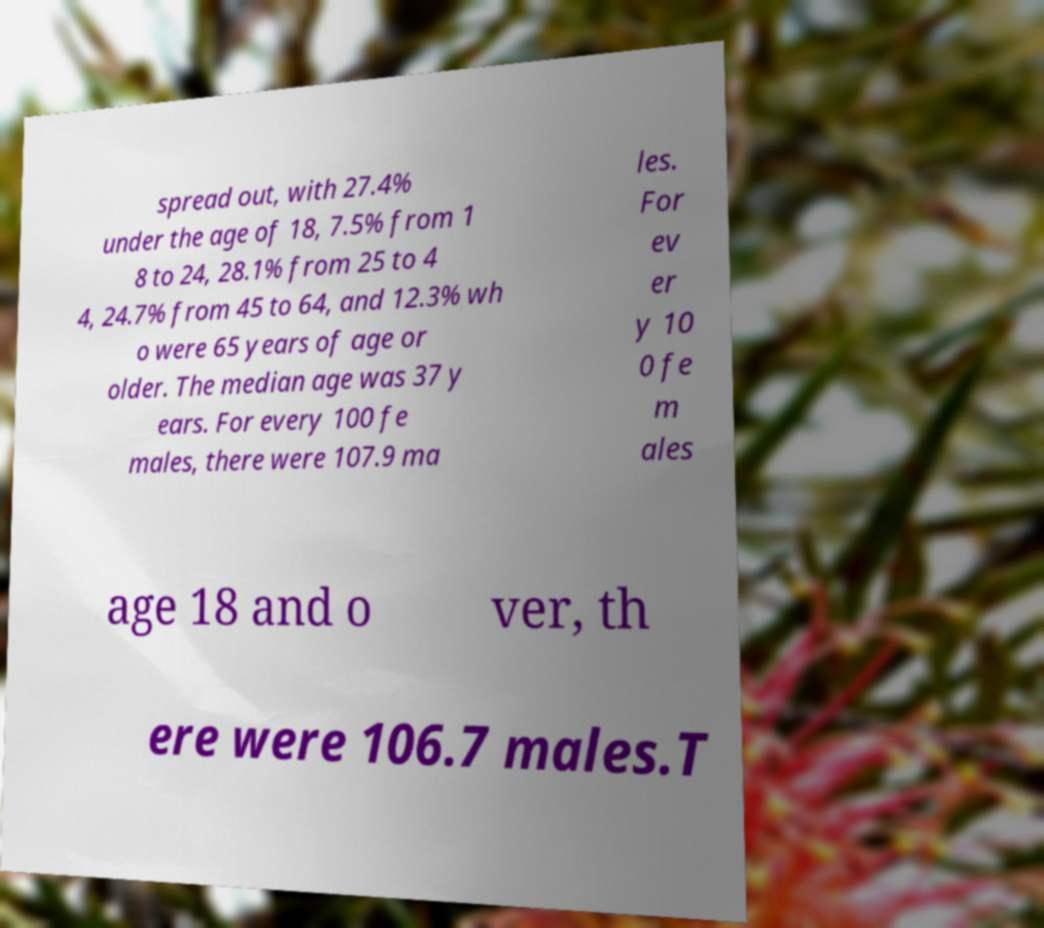Please read and relay the text visible in this image. What does it say? spread out, with 27.4% under the age of 18, 7.5% from 1 8 to 24, 28.1% from 25 to 4 4, 24.7% from 45 to 64, and 12.3% wh o were 65 years of age or older. The median age was 37 y ears. For every 100 fe males, there were 107.9 ma les. For ev er y 10 0 fe m ales age 18 and o ver, th ere were 106.7 males.T 